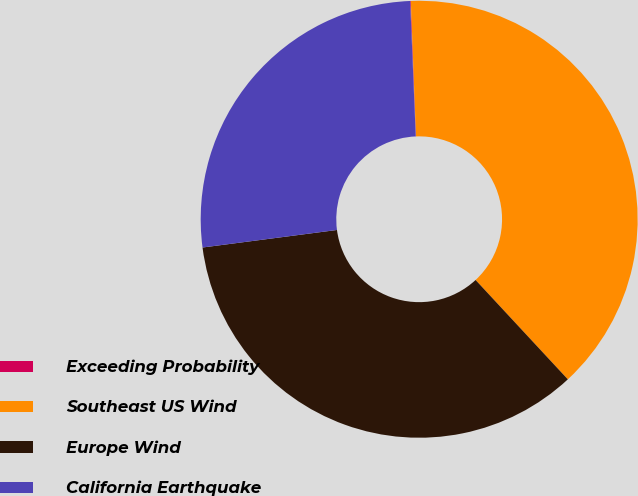Convert chart to OTSL. <chart><loc_0><loc_0><loc_500><loc_500><pie_chart><fcel>Exceeding Probability<fcel>Southeast US Wind<fcel>Europe Wind<fcel>California Earthquake<nl><fcel>0.05%<fcel>38.7%<fcel>34.85%<fcel>26.41%<nl></chart> 